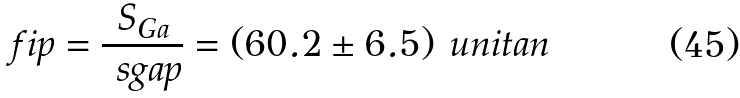Convert formula to latex. <formula><loc_0><loc_0><loc_500><loc_500>\ f i p = \frac { S _ { G a } } { \ s g a p } = ( 6 0 . 2 \pm 6 . 5 ) { \mbox \ u n i t a n }</formula> 